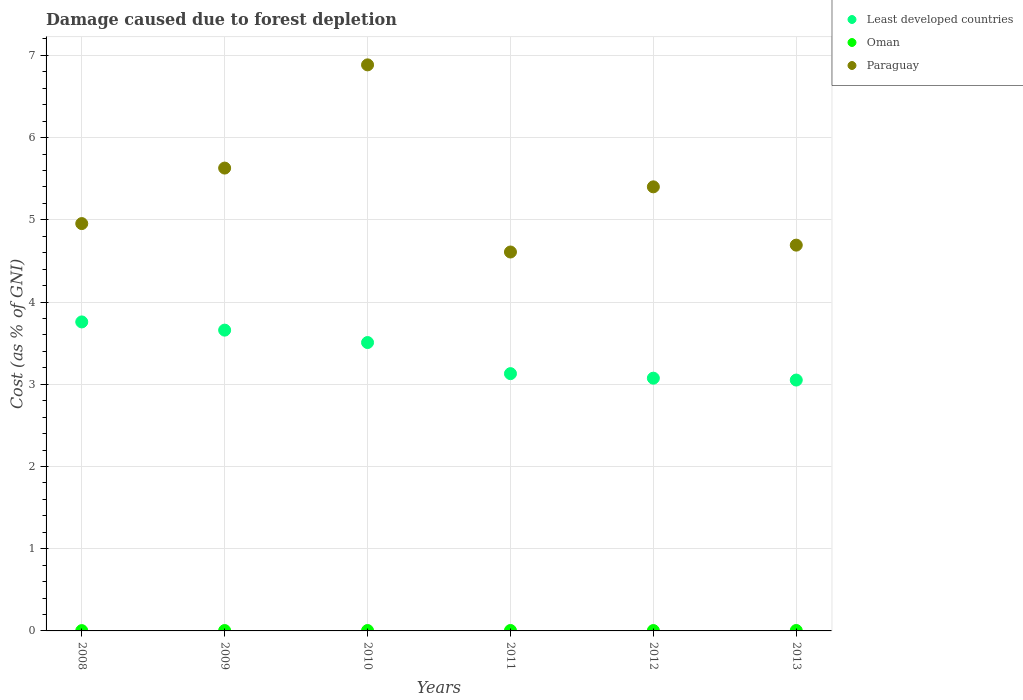How many different coloured dotlines are there?
Make the answer very short. 3. Is the number of dotlines equal to the number of legend labels?
Make the answer very short. Yes. What is the cost of damage caused due to forest depletion in Least developed countries in 2008?
Your answer should be compact. 3.76. Across all years, what is the maximum cost of damage caused due to forest depletion in Paraguay?
Offer a very short reply. 6.88. Across all years, what is the minimum cost of damage caused due to forest depletion in Least developed countries?
Your response must be concise. 3.05. In which year was the cost of damage caused due to forest depletion in Paraguay minimum?
Your answer should be compact. 2011. What is the total cost of damage caused due to forest depletion in Oman in the graph?
Provide a short and direct response. 0.03. What is the difference between the cost of damage caused due to forest depletion in Paraguay in 2009 and that in 2011?
Give a very brief answer. 1.02. What is the difference between the cost of damage caused due to forest depletion in Oman in 2008 and the cost of damage caused due to forest depletion in Least developed countries in 2010?
Offer a very short reply. -3.5. What is the average cost of damage caused due to forest depletion in Paraguay per year?
Keep it short and to the point. 5.36. In the year 2012, what is the difference between the cost of damage caused due to forest depletion in Least developed countries and cost of damage caused due to forest depletion in Paraguay?
Offer a terse response. -2.33. What is the ratio of the cost of damage caused due to forest depletion in Paraguay in 2010 to that in 2011?
Provide a short and direct response. 1.49. What is the difference between the highest and the second highest cost of damage caused due to forest depletion in Paraguay?
Make the answer very short. 1.26. What is the difference between the highest and the lowest cost of damage caused due to forest depletion in Least developed countries?
Your response must be concise. 0.71. Is it the case that in every year, the sum of the cost of damage caused due to forest depletion in Paraguay and cost of damage caused due to forest depletion in Oman  is greater than the cost of damage caused due to forest depletion in Least developed countries?
Your response must be concise. Yes. Is the cost of damage caused due to forest depletion in Paraguay strictly less than the cost of damage caused due to forest depletion in Least developed countries over the years?
Make the answer very short. No. Does the graph contain grids?
Ensure brevity in your answer.  Yes. Where does the legend appear in the graph?
Give a very brief answer. Top right. What is the title of the graph?
Keep it short and to the point. Damage caused due to forest depletion. Does "Thailand" appear as one of the legend labels in the graph?
Offer a terse response. No. What is the label or title of the Y-axis?
Your answer should be very brief. Cost (as % of GNI). What is the Cost (as % of GNI) in Least developed countries in 2008?
Your answer should be very brief. 3.76. What is the Cost (as % of GNI) in Oman in 2008?
Keep it short and to the point. 0. What is the Cost (as % of GNI) of Paraguay in 2008?
Provide a succinct answer. 4.95. What is the Cost (as % of GNI) of Least developed countries in 2009?
Keep it short and to the point. 3.66. What is the Cost (as % of GNI) of Oman in 2009?
Ensure brevity in your answer.  0. What is the Cost (as % of GNI) in Paraguay in 2009?
Keep it short and to the point. 5.63. What is the Cost (as % of GNI) of Least developed countries in 2010?
Your answer should be very brief. 3.51. What is the Cost (as % of GNI) in Oman in 2010?
Offer a terse response. 0. What is the Cost (as % of GNI) of Paraguay in 2010?
Your answer should be very brief. 6.88. What is the Cost (as % of GNI) in Least developed countries in 2011?
Give a very brief answer. 3.13. What is the Cost (as % of GNI) in Oman in 2011?
Provide a succinct answer. 0.01. What is the Cost (as % of GNI) of Paraguay in 2011?
Provide a succinct answer. 4.61. What is the Cost (as % of GNI) in Least developed countries in 2012?
Keep it short and to the point. 3.07. What is the Cost (as % of GNI) in Oman in 2012?
Your answer should be very brief. 0. What is the Cost (as % of GNI) of Paraguay in 2012?
Your response must be concise. 5.4. What is the Cost (as % of GNI) in Least developed countries in 2013?
Provide a short and direct response. 3.05. What is the Cost (as % of GNI) of Oman in 2013?
Give a very brief answer. 0.01. What is the Cost (as % of GNI) of Paraguay in 2013?
Your response must be concise. 4.69. Across all years, what is the maximum Cost (as % of GNI) of Least developed countries?
Provide a succinct answer. 3.76. Across all years, what is the maximum Cost (as % of GNI) in Oman?
Make the answer very short. 0.01. Across all years, what is the maximum Cost (as % of GNI) in Paraguay?
Provide a succinct answer. 6.88. Across all years, what is the minimum Cost (as % of GNI) in Least developed countries?
Offer a very short reply. 3.05. Across all years, what is the minimum Cost (as % of GNI) in Oman?
Your answer should be very brief. 0. Across all years, what is the minimum Cost (as % of GNI) of Paraguay?
Your response must be concise. 4.61. What is the total Cost (as % of GNI) in Least developed countries in the graph?
Your response must be concise. 20.18. What is the total Cost (as % of GNI) in Oman in the graph?
Your answer should be very brief. 0.03. What is the total Cost (as % of GNI) in Paraguay in the graph?
Your response must be concise. 32.17. What is the difference between the Cost (as % of GNI) in Least developed countries in 2008 and that in 2009?
Keep it short and to the point. 0.1. What is the difference between the Cost (as % of GNI) of Oman in 2008 and that in 2009?
Offer a very short reply. -0. What is the difference between the Cost (as % of GNI) of Paraguay in 2008 and that in 2009?
Make the answer very short. -0.68. What is the difference between the Cost (as % of GNI) of Least developed countries in 2008 and that in 2010?
Provide a succinct answer. 0.25. What is the difference between the Cost (as % of GNI) of Oman in 2008 and that in 2010?
Make the answer very short. -0. What is the difference between the Cost (as % of GNI) in Paraguay in 2008 and that in 2010?
Your answer should be very brief. -1.93. What is the difference between the Cost (as % of GNI) in Least developed countries in 2008 and that in 2011?
Provide a succinct answer. 0.63. What is the difference between the Cost (as % of GNI) of Oman in 2008 and that in 2011?
Offer a terse response. -0. What is the difference between the Cost (as % of GNI) in Paraguay in 2008 and that in 2011?
Provide a short and direct response. 0.35. What is the difference between the Cost (as % of GNI) of Least developed countries in 2008 and that in 2012?
Provide a short and direct response. 0.68. What is the difference between the Cost (as % of GNI) in Oman in 2008 and that in 2012?
Ensure brevity in your answer.  -0. What is the difference between the Cost (as % of GNI) in Paraguay in 2008 and that in 2012?
Your answer should be very brief. -0.45. What is the difference between the Cost (as % of GNI) of Least developed countries in 2008 and that in 2013?
Your answer should be compact. 0.71. What is the difference between the Cost (as % of GNI) of Oman in 2008 and that in 2013?
Offer a terse response. -0. What is the difference between the Cost (as % of GNI) in Paraguay in 2008 and that in 2013?
Your answer should be very brief. 0.26. What is the difference between the Cost (as % of GNI) of Least developed countries in 2009 and that in 2010?
Provide a succinct answer. 0.15. What is the difference between the Cost (as % of GNI) in Oman in 2009 and that in 2010?
Keep it short and to the point. -0. What is the difference between the Cost (as % of GNI) of Paraguay in 2009 and that in 2010?
Offer a very short reply. -1.26. What is the difference between the Cost (as % of GNI) of Least developed countries in 2009 and that in 2011?
Keep it short and to the point. 0.53. What is the difference between the Cost (as % of GNI) in Oman in 2009 and that in 2011?
Give a very brief answer. -0. What is the difference between the Cost (as % of GNI) of Paraguay in 2009 and that in 2011?
Your answer should be very brief. 1.02. What is the difference between the Cost (as % of GNI) in Least developed countries in 2009 and that in 2012?
Ensure brevity in your answer.  0.58. What is the difference between the Cost (as % of GNI) in Oman in 2009 and that in 2012?
Offer a terse response. 0. What is the difference between the Cost (as % of GNI) of Paraguay in 2009 and that in 2012?
Your answer should be very brief. 0.23. What is the difference between the Cost (as % of GNI) in Least developed countries in 2009 and that in 2013?
Give a very brief answer. 0.61. What is the difference between the Cost (as % of GNI) in Oman in 2009 and that in 2013?
Make the answer very short. -0. What is the difference between the Cost (as % of GNI) of Paraguay in 2009 and that in 2013?
Provide a succinct answer. 0.94. What is the difference between the Cost (as % of GNI) in Least developed countries in 2010 and that in 2011?
Your answer should be compact. 0.38. What is the difference between the Cost (as % of GNI) of Oman in 2010 and that in 2011?
Your answer should be compact. -0. What is the difference between the Cost (as % of GNI) of Paraguay in 2010 and that in 2011?
Ensure brevity in your answer.  2.28. What is the difference between the Cost (as % of GNI) in Least developed countries in 2010 and that in 2012?
Your response must be concise. 0.43. What is the difference between the Cost (as % of GNI) in Oman in 2010 and that in 2012?
Offer a terse response. 0. What is the difference between the Cost (as % of GNI) in Paraguay in 2010 and that in 2012?
Provide a succinct answer. 1.48. What is the difference between the Cost (as % of GNI) in Least developed countries in 2010 and that in 2013?
Your response must be concise. 0.46. What is the difference between the Cost (as % of GNI) of Oman in 2010 and that in 2013?
Offer a terse response. -0. What is the difference between the Cost (as % of GNI) in Paraguay in 2010 and that in 2013?
Keep it short and to the point. 2.19. What is the difference between the Cost (as % of GNI) in Least developed countries in 2011 and that in 2012?
Your answer should be very brief. 0.06. What is the difference between the Cost (as % of GNI) of Oman in 2011 and that in 2012?
Keep it short and to the point. 0. What is the difference between the Cost (as % of GNI) in Paraguay in 2011 and that in 2012?
Provide a short and direct response. -0.79. What is the difference between the Cost (as % of GNI) of Least developed countries in 2011 and that in 2013?
Give a very brief answer. 0.08. What is the difference between the Cost (as % of GNI) of Paraguay in 2011 and that in 2013?
Offer a terse response. -0.08. What is the difference between the Cost (as % of GNI) of Least developed countries in 2012 and that in 2013?
Offer a terse response. 0.02. What is the difference between the Cost (as % of GNI) of Oman in 2012 and that in 2013?
Your answer should be very brief. -0. What is the difference between the Cost (as % of GNI) of Paraguay in 2012 and that in 2013?
Keep it short and to the point. 0.71. What is the difference between the Cost (as % of GNI) of Least developed countries in 2008 and the Cost (as % of GNI) of Oman in 2009?
Your answer should be compact. 3.75. What is the difference between the Cost (as % of GNI) of Least developed countries in 2008 and the Cost (as % of GNI) of Paraguay in 2009?
Offer a very short reply. -1.87. What is the difference between the Cost (as % of GNI) in Oman in 2008 and the Cost (as % of GNI) in Paraguay in 2009?
Keep it short and to the point. -5.63. What is the difference between the Cost (as % of GNI) in Least developed countries in 2008 and the Cost (as % of GNI) in Oman in 2010?
Provide a short and direct response. 3.75. What is the difference between the Cost (as % of GNI) of Least developed countries in 2008 and the Cost (as % of GNI) of Paraguay in 2010?
Ensure brevity in your answer.  -3.13. What is the difference between the Cost (as % of GNI) in Oman in 2008 and the Cost (as % of GNI) in Paraguay in 2010?
Your answer should be very brief. -6.88. What is the difference between the Cost (as % of GNI) in Least developed countries in 2008 and the Cost (as % of GNI) in Oman in 2011?
Your answer should be compact. 3.75. What is the difference between the Cost (as % of GNI) in Least developed countries in 2008 and the Cost (as % of GNI) in Paraguay in 2011?
Keep it short and to the point. -0.85. What is the difference between the Cost (as % of GNI) in Oman in 2008 and the Cost (as % of GNI) in Paraguay in 2011?
Provide a short and direct response. -4.6. What is the difference between the Cost (as % of GNI) in Least developed countries in 2008 and the Cost (as % of GNI) in Oman in 2012?
Offer a terse response. 3.75. What is the difference between the Cost (as % of GNI) of Least developed countries in 2008 and the Cost (as % of GNI) of Paraguay in 2012?
Your answer should be very brief. -1.64. What is the difference between the Cost (as % of GNI) in Oman in 2008 and the Cost (as % of GNI) in Paraguay in 2012?
Provide a succinct answer. -5.4. What is the difference between the Cost (as % of GNI) of Least developed countries in 2008 and the Cost (as % of GNI) of Oman in 2013?
Your response must be concise. 3.75. What is the difference between the Cost (as % of GNI) of Least developed countries in 2008 and the Cost (as % of GNI) of Paraguay in 2013?
Offer a very short reply. -0.93. What is the difference between the Cost (as % of GNI) in Oman in 2008 and the Cost (as % of GNI) in Paraguay in 2013?
Keep it short and to the point. -4.69. What is the difference between the Cost (as % of GNI) of Least developed countries in 2009 and the Cost (as % of GNI) of Oman in 2010?
Give a very brief answer. 3.65. What is the difference between the Cost (as % of GNI) in Least developed countries in 2009 and the Cost (as % of GNI) in Paraguay in 2010?
Offer a very short reply. -3.23. What is the difference between the Cost (as % of GNI) in Oman in 2009 and the Cost (as % of GNI) in Paraguay in 2010?
Keep it short and to the point. -6.88. What is the difference between the Cost (as % of GNI) of Least developed countries in 2009 and the Cost (as % of GNI) of Oman in 2011?
Your answer should be very brief. 3.65. What is the difference between the Cost (as % of GNI) in Least developed countries in 2009 and the Cost (as % of GNI) in Paraguay in 2011?
Keep it short and to the point. -0.95. What is the difference between the Cost (as % of GNI) of Oman in 2009 and the Cost (as % of GNI) of Paraguay in 2011?
Offer a very short reply. -4.6. What is the difference between the Cost (as % of GNI) of Least developed countries in 2009 and the Cost (as % of GNI) of Oman in 2012?
Provide a succinct answer. 3.65. What is the difference between the Cost (as % of GNI) in Least developed countries in 2009 and the Cost (as % of GNI) in Paraguay in 2012?
Make the answer very short. -1.74. What is the difference between the Cost (as % of GNI) of Oman in 2009 and the Cost (as % of GNI) of Paraguay in 2012?
Provide a short and direct response. -5.4. What is the difference between the Cost (as % of GNI) in Least developed countries in 2009 and the Cost (as % of GNI) in Oman in 2013?
Ensure brevity in your answer.  3.65. What is the difference between the Cost (as % of GNI) in Least developed countries in 2009 and the Cost (as % of GNI) in Paraguay in 2013?
Offer a terse response. -1.03. What is the difference between the Cost (as % of GNI) of Oman in 2009 and the Cost (as % of GNI) of Paraguay in 2013?
Your response must be concise. -4.69. What is the difference between the Cost (as % of GNI) in Least developed countries in 2010 and the Cost (as % of GNI) in Oman in 2011?
Your answer should be very brief. 3.5. What is the difference between the Cost (as % of GNI) of Least developed countries in 2010 and the Cost (as % of GNI) of Paraguay in 2011?
Offer a very short reply. -1.1. What is the difference between the Cost (as % of GNI) in Oman in 2010 and the Cost (as % of GNI) in Paraguay in 2011?
Give a very brief answer. -4.6. What is the difference between the Cost (as % of GNI) of Least developed countries in 2010 and the Cost (as % of GNI) of Oman in 2012?
Make the answer very short. 3.5. What is the difference between the Cost (as % of GNI) of Least developed countries in 2010 and the Cost (as % of GNI) of Paraguay in 2012?
Offer a very short reply. -1.89. What is the difference between the Cost (as % of GNI) in Oman in 2010 and the Cost (as % of GNI) in Paraguay in 2012?
Your answer should be very brief. -5.4. What is the difference between the Cost (as % of GNI) of Least developed countries in 2010 and the Cost (as % of GNI) of Oman in 2013?
Offer a terse response. 3.5. What is the difference between the Cost (as % of GNI) in Least developed countries in 2010 and the Cost (as % of GNI) in Paraguay in 2013?
Offer a very short reply. -1.18. What is the difference between the Cost (as % of GNI) in Oman in 2010 and the Cost (as % of GNI) in Paraguay in 2013?
Your answer should be compact. -4.69. What is the difference between the Cost (as % of GNI) of Least developed countries in 2011 and the Cost (as % of GNI) of Oman in 2012?
Give a very brief answer. 3.12. What is the difference between the Cost (as % of GNI) of Least developed countries in 2011 and the Cost (as % of GNI) of Paraguay in 2012?
Provide a short and direct response. -2.27. What is the difference between the Cost (as % of GNI) of Oman in 2011 and the Cost (as % of GNI) of Paraguay in 2012?
Ensure brevity in your answer.  -5.4. What is the difference between the Cost (as % of GNI) in Least developed countries in 2011 and the Cost (as % of GNI) in Oman in 2013?
Offer a very short reply. 3.12. What is the difference between the Cost (as % of GNI) in Least developed countries in 2011 and the Cost (as % of GNI) in Paraguay in 2013?
Offer a terse response. -1.56. What is the difference between the Cost (as % of GNI) of Oman in 2011 and the Cost (as % of GNI) of Paraguay in 2013?
Make the answer very short. -4.69. What is the difference between the Cost (as % of GNI) of Least developed countries in 2012 and the Cost (as % of GNI) of Oman in 2013?
Your answer should be very brief. 3.07. What is the difference between the Cost (as % of GNI) of Least developed countries in 2012 and the Cost (as % of GNI) of Paraguay in 2013?
Make the answer very short. -1.62. What is the difference between the Cost (as % of GNI) of Oman in 2012 and the Cost (as % of GNI) of Paraguay in 2013?
Make the answer very short. -4.69. What is the average Cost (as % of GNI) in Least developed countries per year?
Your answer should be very brief. 3.36. What is the average Cost (as % of GNI) of Oman per year?
Offer a terse response. 0. What is the average Cost (as % of GNI) of Paraguay per year?
Your answer should be very brief. 5.36. In the year 2008, what is the difference between the Cost (as % of GNI) in Least developed countries and Cost (as % of GNI) in Oman?
Give a very brief answer. 3.75. In the year 2008, what is the difference between the Cost (as % of GNI) of Least developed countries and Cost (as % of GNI) of Paraguay?
Ensure brevity in your answer.  -1.2. In the year 2008, what is the difference between the Cost (as % of GNI) in Oman and Cost (as % of GNI) in Paraguay?
Your answer should be very brief. -4.95. In the year 2009, what is the difference between the Cost (as % of GNI) of Least developed countries and Cost (as % of GNI) of Oman?
Make the answer very short. 3.65. In the year 2009, what is the difference between the Cost (as % of GNI) of Least developed countries and Cost (as % of GNI) of Paraguay?
Make the answer very short. -1.97. In the year 2009, what is the difference between the Cost (as % of GNI) in Oman and Cost (as % of GNI) in Paraguay?
Offer a terse response. -5.62. In the year 2010, what is the difference between the Cost (as % of GNI) in Least developed countries and Cost (as % of GNI) in Oman?
Provide a short and direct response. 3.5. In the year 2010, what is the difference between the Cost (as % of GNI) in Least developed countries and Cost (as % of GNI) in Paraguay?
Your response must be concise. -3.38. In the year 2010, what is the difference between the Cost (as % of GNI) of Oman and Cost (as % of GNI) of Paraguay?
Your response must be concise. -6.88. In the year 2011, what is the difference between the Cost (as % of GNI) of Least developed countries and Cost (as % of GNI) of Oman?
Keep it short and to the point. 3.12. In the year 2011, what is the difference between the Cost (as % of GNI) in Least developed countries and Cost (as % of GNI) in Paraguay?
Give a very brief answer. -1.48. In the year 2011, what is the difference between the Cost (as % of GNI) of Oman and Cost (as % of GNI) of Paraguay?
Your answer should be compact. -4.6. In the year 2012, what is the difference between the Cost (as % of GNI) in Least developed countries and Cost (as % of GNI) in Oman?
Provide a short and direct response. 3.07. In the year 2012, what is the difference between the Cost (as % of GNI) in Least developed countries and Cost (as % of GNI) in Paraguay?
Offer a terse response. -2.33. In the year 2012, what is the difference between the Cost (as % of GNI) in Oman and Cost (as % of GNI) in Paraguay?
Keep it short and to the point. -5.4. In the year 2013, what is the difference between the Cost (as % of GNI) of Least developed countries and Cost (as % of GNI) of Oman?
Offer a terse response. 3.05. In the year 2013, what is the difference between the Cost (as % of GNI) in Least developed countries and Cost (as % of GNI) in Paraguay?
Your answer should be very brief. -1.64. In the year 2013, what is the difference between the Cost (as % of GNI) of Oman and Cost (as % of GNI) of Paraguay?
Your answer should be compact. -4.69. What is the ratio of the Cost (as % of GNI) of Least developed countries in 2008 to that in 2009?
Your response must be concise. 1.03. What is the ratio of the Cost (as % of GNI) in Oman in 2008 to that in 2009?
Offer a very short reply. 0.78. What is the ratio of the Cost (as % of GNI) in Paraguay in 2008 to that in 2009?
Offer a very short reply. 0.88. What is the ratio of the Cost (as % of GNI) in Least developed countries in 2008 to that in 2010?
Your answer should be compact. 1.07. What is the ratio of the Cost (as % of GNI) in Oman in 2008 to that in 2010?
Make the answer very short. 0.76. What is the ratio of the Cost (as % of GNI) of Paraguay in 2008 to that in 2010?
Your answer should be compact. 0.72. What is the ratio of the Cost (as % of GNI) of Least developed countries in 2008 to that in 2011?
Provide a succinct answer. 1.2. What is the ratio of the Cost (as % of GNI) in Oman in 2008 to that in 2011?
Give a very brief answer. 0.71. What is the ratio of the Cost (as % of GNI) of Paraguay in 2008 to that in 2011?
Offer a very short reply. 1.07. What is the ratio of the Cost (as % of GNI) in Least developed countries in 2008 to that in 2012?
Make the answer very short. 1.22. What is the ratio of the Cost (as % of GNI) in Oman in 2008 to that in 2012?
Your answer should be compact. 0.81. What is the ratio of the Cost (as % of GNI) of Paraguay in 2008 to that in 2012?
Provide a short and direct response. 0.92. What is the ratio of the Cost (as % of GNI) of Least developed countries in 2008 to that in 2013?
Your answer should be very brief. 1.23. What is the ratio of the Cost (as % of GNI) of Oman in 2008 to that in 2013?
Keep it short and to the point. 0.71. What is the ratio of the Cost (as % of GNI) of Paraguay in 2008 to that in 2013?
Provide a short and direct response. 1.06. What is the ratio of the Cost (as % of GNI) of Least developed countries in 2009 to that in 2010?
Ensure brevity in your answer.  1.04. What is the ratio of the Cost (as % of GNI) in Oman in 2009 to that in 2010?
Keep it short and to the point. 0.97. What is the ratio of the Cost (as % of GNI) in Paraguay in 2009 to that in 2010?
Offer a very short reply. 0.82. What is the ratio of the Cost (as % of GNI) in Least developed countries in 2009 to that in 2011?
Ensure brevity in your answer.  1.17. What is the ratio of the Cost (as % of GNI) of Oman in 2009 to that in 2011?
Provide a succinct answer. 0.91. What is the ratio of the Cost (as % of GNI) in Paraguay in 2009 to that in 2011?
Offer a terse response. 1.22. What is the ratio of the Cost (as % of GNI) of Least developed countries in 2009 to that in 2012?
Offer a terse response. 1.19. What is the ratio of the Cost (as % of GNI) of Oman in 2009 to that in 2012?
Make the answer very short. 1.04. What is the ratio of the Cost (as % of GNI) of Paraguay in 2009 to that in 2012?
Make the answer very short. 1.04. What is the ratio of the Cost (as % of GNI) of Least developed countries in 2009 to that in 2013?
Offer a very short reply. 1.2. What is the ratio of the Cost (as % of GNI) in Oman in 2009 to that in 2013?
Your answer should be compact. 0.91. What is the ratio of the Cost (as % of GNI) in Paraguay in 2009 to that in 2013?
Ensure brevity in your answer.  1.2. What is the ratio of the Cost (as % of GNI) in Least developed countries in 2010 to that in 2011?
Ensure brevity in your answer.  1.12. What is the ratio of the Cost (as % of GNI) in Oman in 2010 to that in 2011?
Offer a terse response. 0.94. What is the ratio of the Cost (as % of GNI) in Paraguay in 2010 to that in 2011?
Your answer should be very brief. 1.49. What is the ratio of the Cost (as % of GNI) in Least developed countries in 2010 to that in 2012?
Your response must be concise. 1.14. What is the ratio of the Cost (as % of GNI) in Oman in 2010 to that in 2012?
Provide a succinct answer. 1.07. What is the ratio of the Cost (as % of GNI) of Paraguay in 2010 to that in 2012?
Offer a terse response. 1.27. What is the ratio of the Cost (as % of GNI) of Least developed countries in 2010 to that in 2013?
Keep it short and to the point. 1.15. What is the ratio of the Cost (as % of GNI) in Oman in 2010 to that in 2013?
Your response must be concise. 0.94. What is the ratio of the Cost (as % of GNI) of Paraguay in 2010 to that in 2013?
Offer a very short reply. 1.47. What is the ratio of the Cost (as % of GNI) in Least developed countries in 2011 to that in 2012?
Offer a very short reply. 1.02. What is the ratio of the Cost (as % of GNI) of Oman in 2011 to that in 2012?
Provide a short and direct response. 1.14. What is the ratio of the Cost (as % of GNI) in Paraguay in 2011 to that in 2012?
Keep it short and to the point. 0.85. What is the ratio of the Cost (as % of GNI) of Least developed countries in 2011 to that in 2013?
Offer a terse response. 1.03. What is the ratio of the Cost (as % of GNI) in Oman in 2011 to that in 2013?
Ensure brevity in your answer.  0.99. What is the ratio of the Cost (as % of GNI) of Paraguay in 2011 to that in 2013?
Ensure brevity in your answer.  0.98. What is the ratio of the Cost (as % of GNI) in Least developed countries in 2012 to that in 2013?
Offer a very short reply. 1.01. What is the ratio of the Cost (as % of GNI) in Oman in 2012 to that in 2013?
Your answer should be very brief. 0.87. What is the ratio of the Cost (as % of GNI) in Paraguay in 2012 to that in 2013?
Your response must be concise. 1.15. What is the difference between the highest and the second highest Cost (as % of GNI) in Least developed countries?
Give a very brief answer. 0.1. What is the difference between the highest and the second highest Cost (as % of GNI) of Paraguay?
Give a very brief answer. 1.26. What is the difference between the highest and the lowest Cost (as % of GNI) of Least developed countries?
Your answer should be compact. 0.71. What is the difference between the highest and the lowest Cost (as % of GNI) of Oman?
Ensure brevity in your answer.  0. What is the difference between the highest and the lowest Cost (as % of GNI) of Paraguay?
Ensure brevity in your answer.  2.28. 